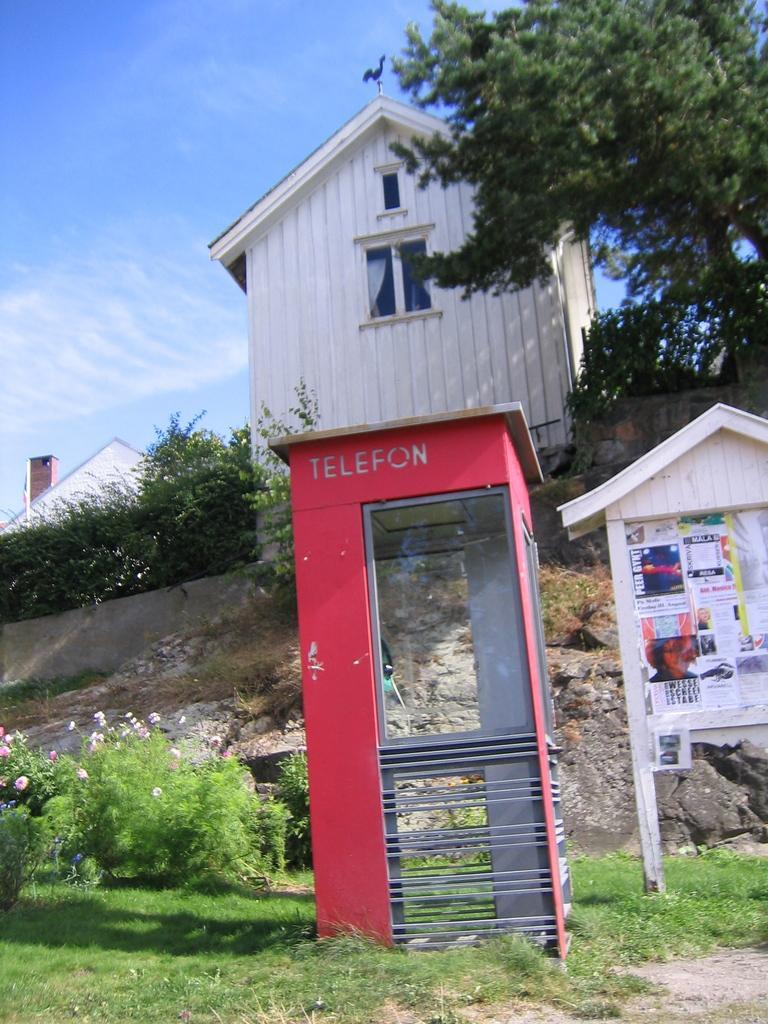How would you summarize this image in a sentence or two? In this image we can see a telephone booth on the ground with some text on it, a wooden roof with some papers pasted on it, some grass, plants with flowers and a wall with stones. On the backside we can see a house with roof and windows, some trees, a pole and the sky which looks cloudy. 